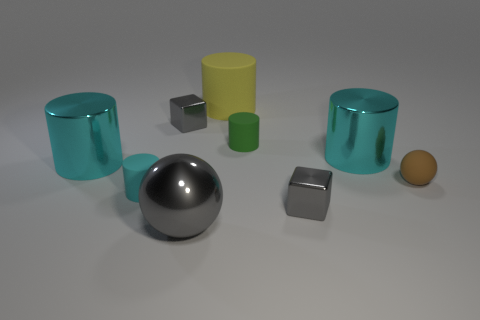Subtract all tiny green rubber cylinders. How many cylinders are left? 4 Subtract 2 spheres. How many spheres are left? 0 Add 1 large cyan metallic cylinders. How many objects exist? 10 Subtract all brown balls. How many balls are left? 1 Subtract all blocks. How many objects are left? 7 Subtract all red balls. Subtract all purple cylinders. How many balls are left? 2 Subtract all green cylinders. How many gray balls are left? 1 Subtract all big cylinders. Subtract all small green matte cylinders. How many objects are left? 5 Add 5 small green things. How many small green things are left? 6 Add 4 large cyan metal spheres. How many large cyan metal spheres exist? 4 